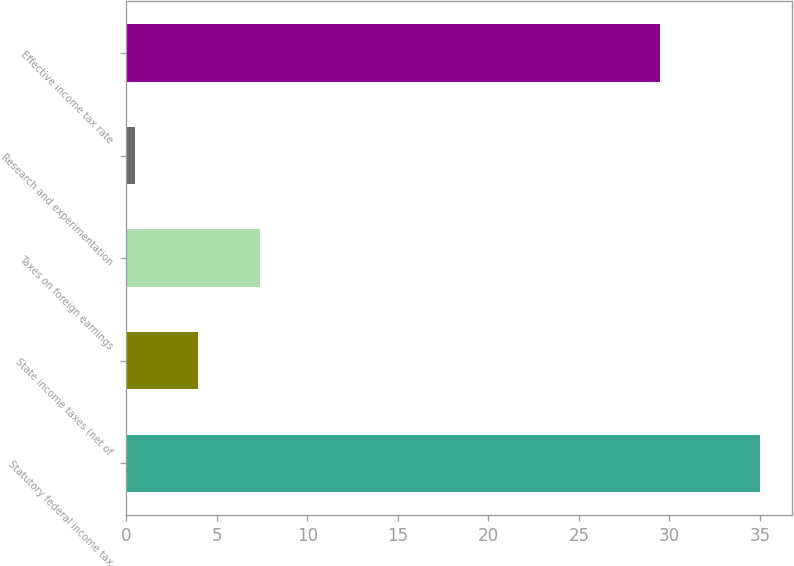Convert chart to OTSL. <chart><loc_0><loc_0><loc_500><loc_500><bar_chart><fcel>Statutory federal income tax<fcel>State income taxes (net of<fcel>Taxes on foreign earnings<fcel>Research and experimentation<fcel>Effective income tax rate<nl><fcel>35<fcel>3.95<fcel>7.4<fcel>0.5<fcel>29.5<nl></chart> 